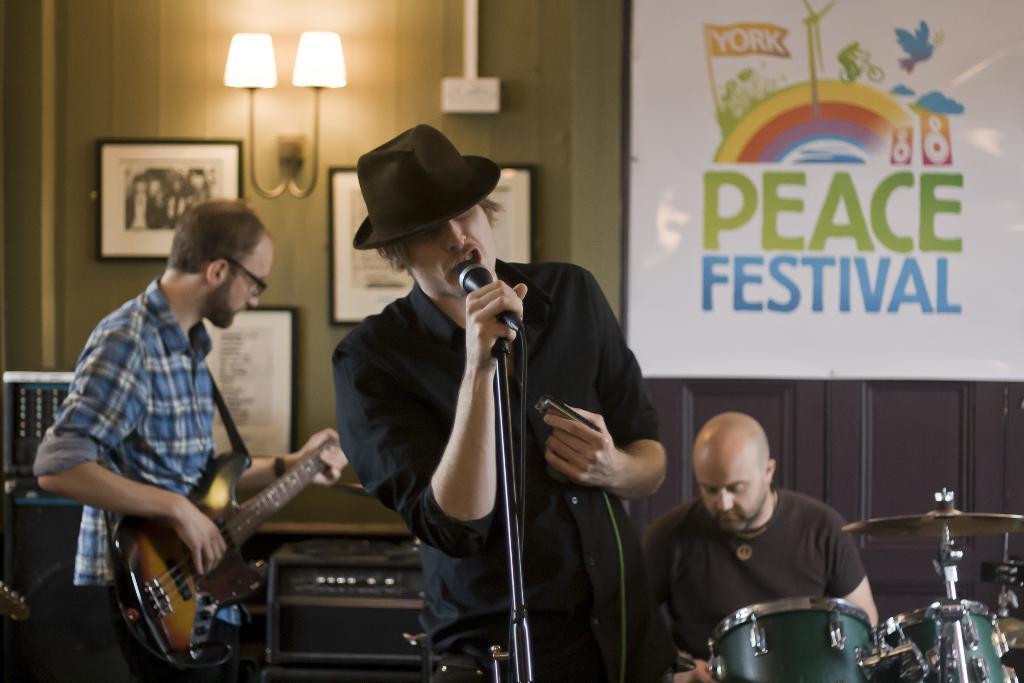Could you give a brief overview of what you see in this image? The person wearing black shirt is standing and singing in front of a mic and there are two people behind him playing musical instruments. 